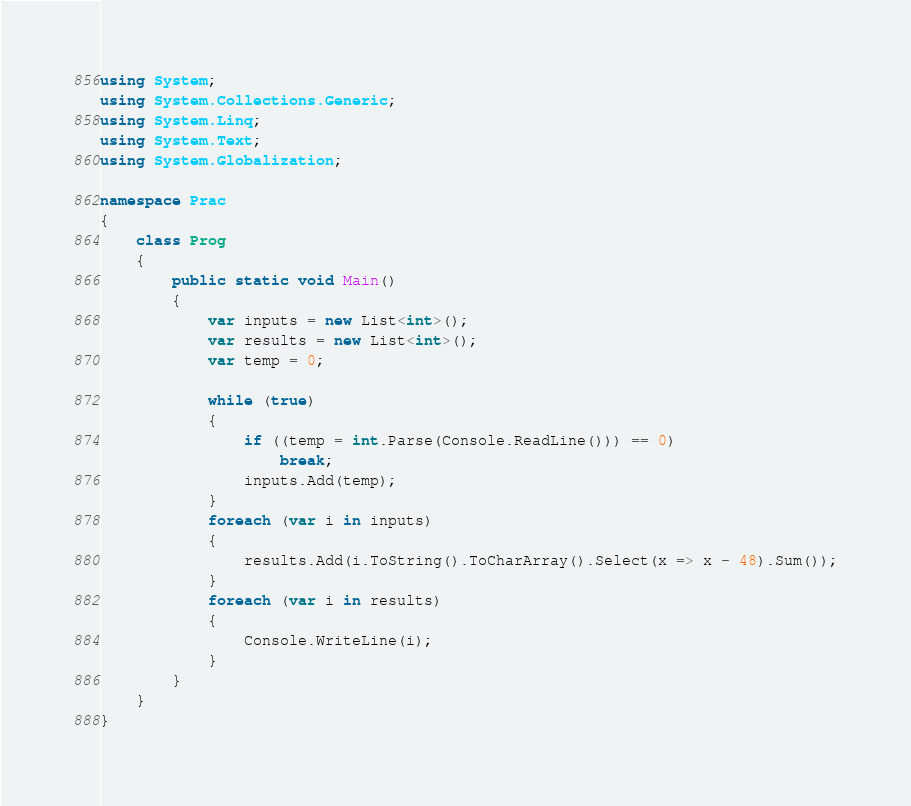<code> <loc_0><loc_0><loc_500><loc_500><_C#_>using System;
using System.Collections.Generic;
using System.Linq;
using System.Text;
using System.Globalization;

namespace Prac
{
    class Prog
    {
        public static void Main()
        {
            var inputs = new List<int>();
            var results = new List<int>();
            var temp = 0;

            while (true)
            {
                if ((temp = int.Parse(Console.ReadLine())) == 0)
                    break;
                inputs.Add(temp);
            }
            foreach (var i in inputs)
            {
                results.Add(i.ToString().ToCharArray().Select(x => x - 48).Sum());
            }
            foreach (var i in results)
            {
                Console.WriteLine(i);
            }
        }
    }
}</code> 